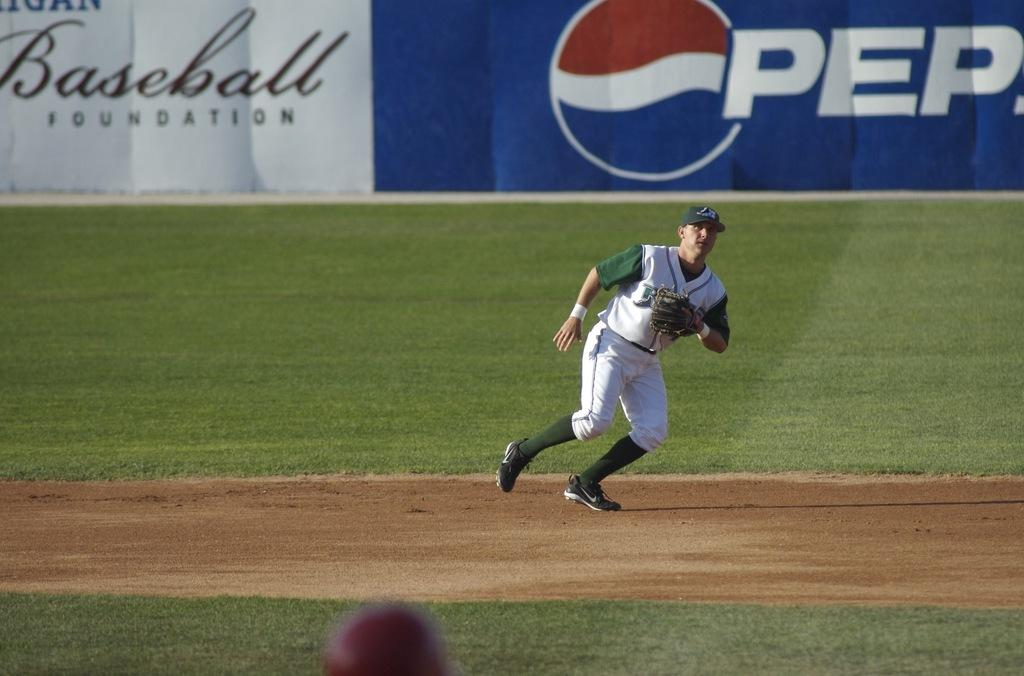<image>
Write a terse but informative summary of the picture. A pro baseball player participates in a game in front of a large Pepsi banner. 